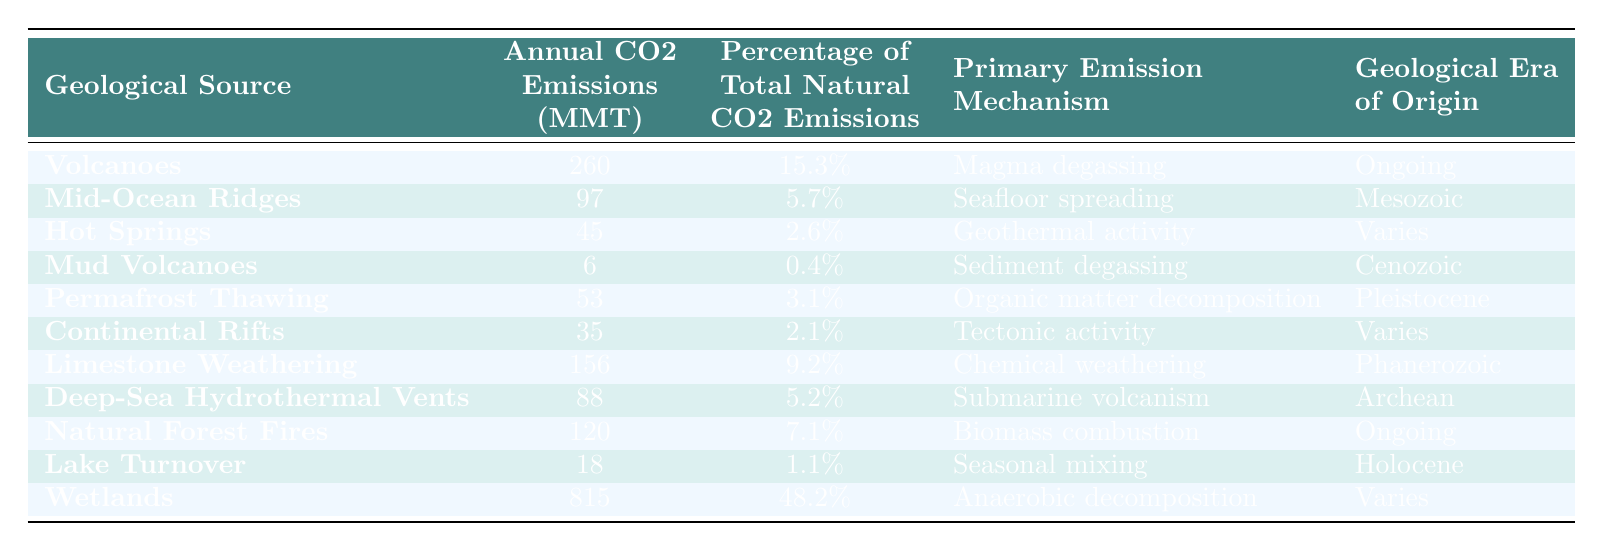What is the annual CO2 emission from wetlands? The table lists the annual CO2 emissions from wetlands as 815 million metric tons.
Answer: 815 million metric tons Which geological source has the highest percentage of total natural CO2 emissions? Wetlands have the highest percentage of total natural CO2 emissions, accounting for 48.2%.
Answer: Wetlands What is the primary emission mechanism for hot springs? The primary emission mechanism for hot springs is geothermal activity, as indicated in the table.
Answer: Geothermal activity Calculate the total CO2 emissions from volcanoes, limestone weathering, and wetlands. Adding the CO2 emissions: 260 (volcanoes) + 156 (limestone weathering) + 815 (wetlands) = 1231 million metric tons.
Answer: 1231 million metric tons Is the emission from mud volcanoes greater than the emission from continental rifts? Mud volcanoes emit 6 million metric tons while continental rifts emit 35 million metric tons, so the emission from mud volcanoes is less than that from continental rifts.
Answer: No What percentage of total natural CO2 emissions do deep-sea hydrothermal vents represent? Deep-sea hydrothermal vents represent 5.2% of total natural CO2 emissions according to the table.
Answer: 5.2% If the total natural CO2 emissions are 1696 million metric tons, what is the combined emission percentage for the three sources: volcanoes, natural forest fires, and wetlands? The emissions are 260 (volcanoes), 120 (natural forest fires), and 815 (wetlands). The combined emissions are 1195 million metric tons. The percentage is (1195/1696)*100 = 70.4%.
Answer: 70.4% What is the geological era of origin for mid-ocean ridges? The table states that mid-ocean ridges originated in the Mesozoic era.
Answer: Mesozoic Are the annual CO2 emissions from hot springs greater than permafrost thawing? Hot springs emit 45 million metric tons, while permafrost thawing emits 53 million metric tons, so the emissions from hot springs are not greater.
Answer: No Which geological source has the lowest CO2 emissions and what is its value? Mud volcanoes have the lowest CO2 emissions at 6 million metric tons, as shown in the table.
Answer: Mud volcanoes, 6 million metric tons 